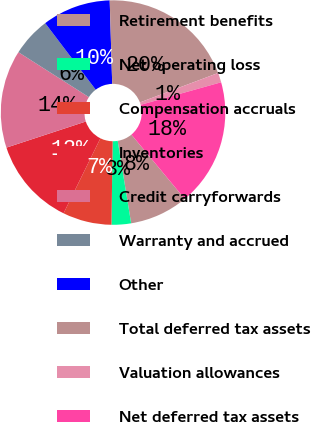Convert chart to OTSL. <chart><loc_0><loc_0><loc_500><loc_500><pie_chart><fcel>Retirement benefits<fcel>Net operating loss<fcel>Compensation accruals<fcel>Inventories<fcel>Credit carryforwards<fcel>Warranty and accrued<fcel>Other<fcel>Total deferred tax assets<fcel>Valuation allowances<fcel>Net deferred tax assets<nl><fcel>8.45%<fcel>2.8%<fcel>7.04%<fcel>12.68%<fcel>14.09%<fcel>5.63%<fcel>9.86%<fcel>19.74%<fcel>1.39%<fcel>18.32%<nl></chart> 